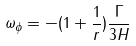Convert formula to latex. <formula><loc_0><loc_0><loc_500><loc_500>\omega _ { \phi } = - ( 1 + \frac { 1 } { r } ) \frac { \Gamma } { 3 H }</formula> 